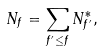Convert formula to latex. <formula><loc_0><loc_0><loc_500><loc_500>N _ { f } = \sum _ { f ^ { \prime } \leq f } N _ { f ^ { \prime } } ^ { \ast } ,</formula> 